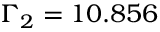Convert formula to latex. <formula><loc_0><loc_0><loc_500><loc_500>\Gamma _ { 2 } = 1 0 . 8 5 6</formula> 